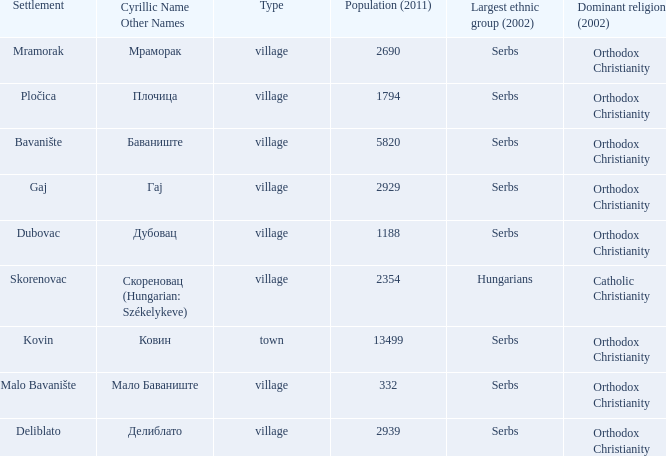What is the Deliblato village known as in Cyrillic? Делиблато. 